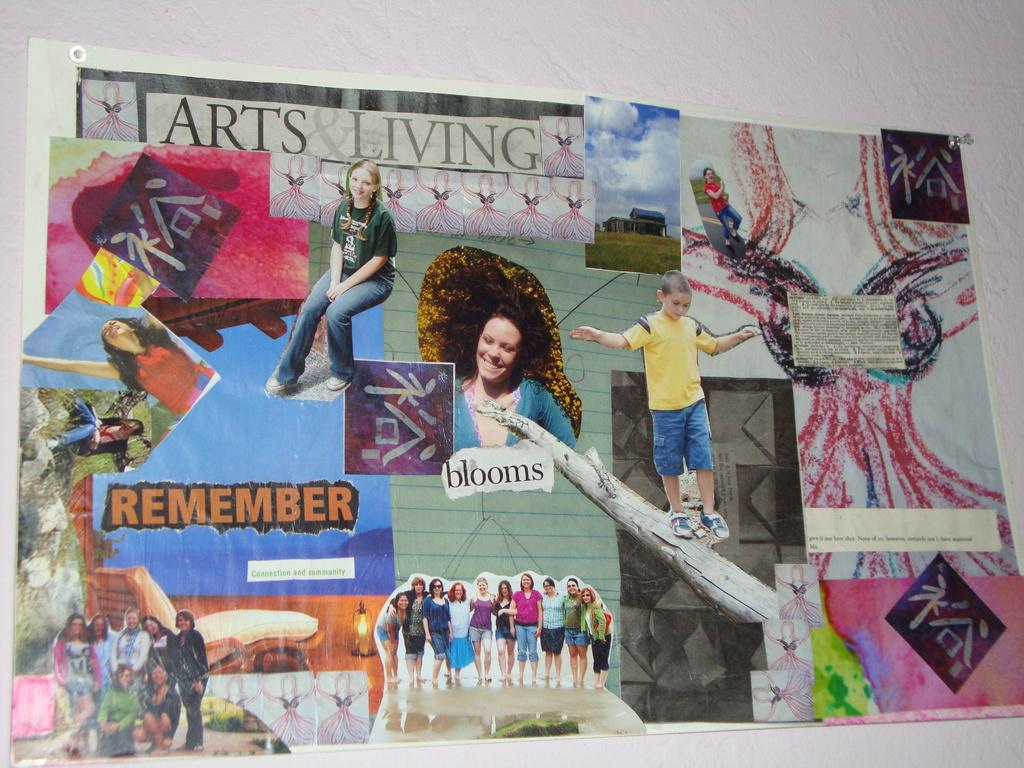<image>
Summarize the visual content of the image. A collage featuring the words "remember" and "blooms" has pictures of several different people. 